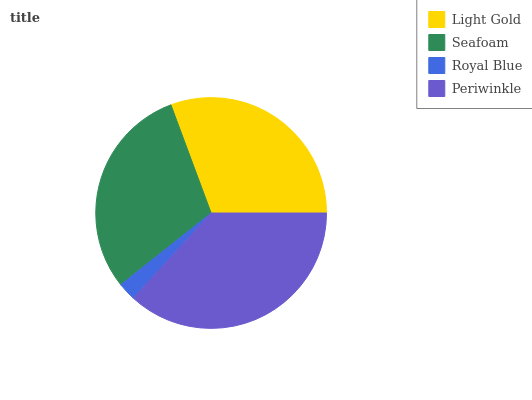Is Royal Blue the minimum?
Answer yes or no. Yes. Is Periwinkle the maximum?
Answer yes or no. Yes. Is Seafoam the minimum?
Answer yes or no. No. Is Seafoam the maximum?
Answer yes or no. No. Is Light Gold greater than Seafoam?
Answer yes or no. Yes. Is Seafoam less than Light Gold?
Answer yes or no. Yes. Is Seafoam greater than Light Gold?
Answer yes or no. No. Is Light Gold less than Seafoam?
Answer yes or no. No. Is Light Gold the high median?
Answer yes or no. Yes. Is Seafoam the low median?
Answer yes or no. Yes. Is Royal Blue the high median?
Answer yes or no. No. Is Royal Blue the low median?
Answer yes or no. No. 